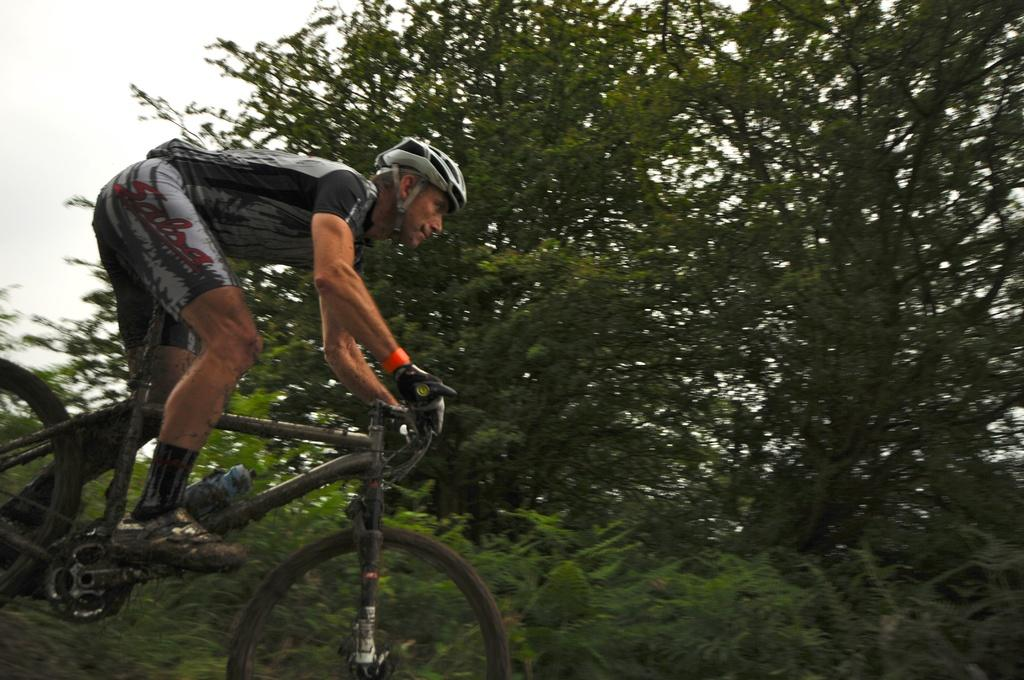What is the main subject of the image? The main subject of the image is a man. What is the man wearing in the image? The man is wearing a helmet in the image. What is the man doing in the image? The man is riding a bicycle in the image. Can you describe any accessories attached to the bicycle? There is a water bottle attached to the bicycle in the image. What can be seen in the background of the image? There are trees in the background of the image. What is visible at the top of the image? The sky is visible at the top of the image. What type of camera can be seen hanging from the man's neck in the image? There is no camera visible in the image; the man is only wearing a helmet and riding a bicycle. How many rings is the man wearing on his fingers in the image? The man is not wearing any rings in the image; he is only wearing a helmet. 